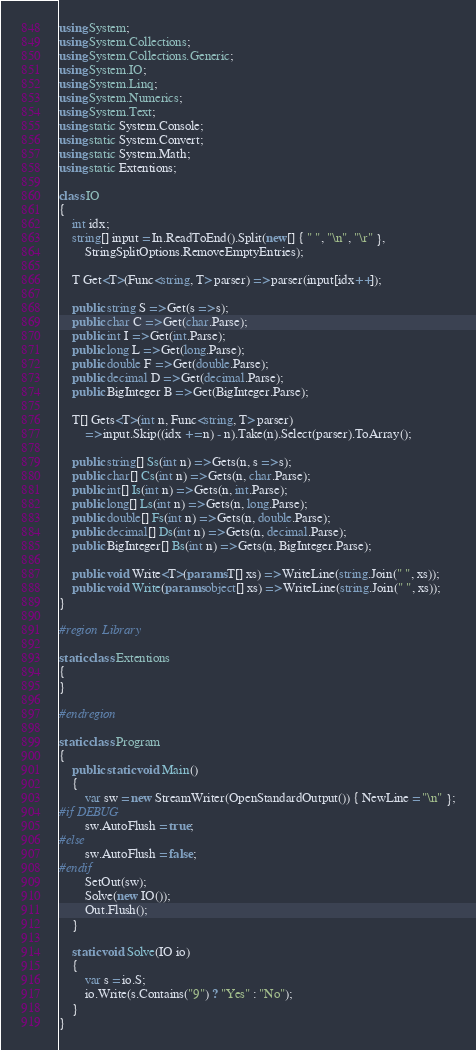Convert code to text. <code><loc_0><loc_0><loc_500><loc_500><_C#_>using System;
using System.Collections;
using System.Collections.Generic;
using System.IO;
using System.Linq;
using System.Numerics;
using System.Text;
using static System.Console;
using static System.Convert;
using static System.Math;
using static Extentions;

class IO
{
    int idx;
    string[] input = In.ReadToEnd().Split(new[] { " ", "\n", "\r" },
        StringSplitOptions.RemoveEmptyEntries);

    T Get<T>(Func<string, T> parser) => parser(input[idx++]);

    public string S => Get(s => s);
    public char C => Get(char.Parse);
    public int I => Get(int.Parse);
    public long L => Get(long.Parse);
    public double F => Get(double.Parse);
    public decimal D => Get(decimal.Parse);
    public BigInteger B => Get(BigInteger.Parse);

    T[] Gets<T>(int n, Func<string, T> parser)
        => input.Skip((idx += n) - n).Take(n).Select(parser).ToArray();

    public string[] Ss(int n) => Gets(n, s => s);
    public char[] Cs(int n) => Gets(n, char.Parse);
    public int[] Is(int n) => Gets(n, int.Parse);
    public long[] Ls(int n) => Gets(n, long.Parse);
    public double[] Fs(int n) => Gets(n, double.Parse);
    public decimal[] Ds(int n) => Gets(n, decimal.Parse);
    public BigInteger[] Bs(int n) => Gets(n, BigInteger.Parse);

    public void Write<T>(params T[] xs) => WriteLine(string.Join(" ", xs));
    public void Write(params object[] xs) => WriteLine(string.Join(" ", xs));
}

#region Library

static class Extentions
{
}

#endregion

static class Program
{
    public static void Main()
    {
        var sw = new StreamWriter(OpenStandardOutput()) { NewLine = "\n" };
#if DEBUG
        sw.AutoFlush = true;
#else
        sw.AutoFlush = false;
#endif
        SetOut(sw);
        Solve(new IO());
        Out.Flush();
    }

    static void Solve(IO io)
    {
        var s = io.S;
        io.Write(s.Contains("9") ? "Yes" : "No");
    }
}</code> 